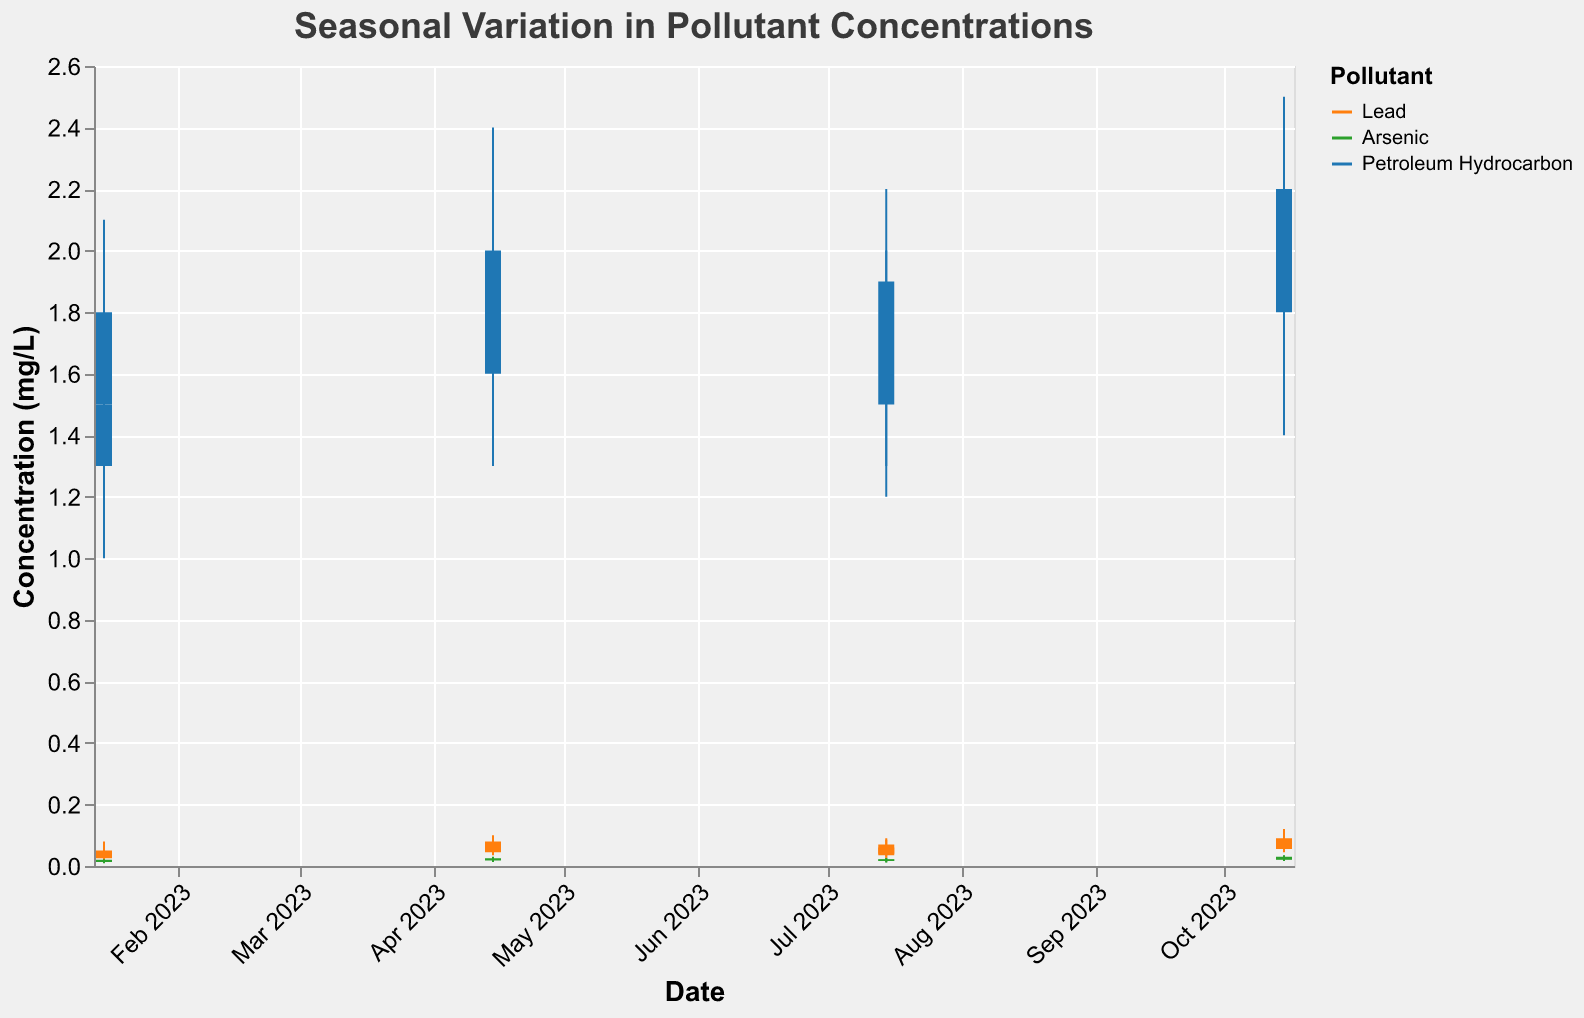What's the title of the figure? The title is displayed at the top of the figure.
Answer: Seasonal Variation in Pollutant Concentrations Which pollutant has the highest concentration in the River Thames in October 2023? Look for the highest "High Concentration (mg/L)" value in the River Thames column for October 2023. Petroleum Hydrocarbon has a high concentration of 2.5 mg/L.
Answer: Petroleum Hydrocarbon What is the average close concentration of Lead in River Thames across all seasons? Sum the close concentrations in River Thames for all seasons and divide by the number of seasons. (0.05 + 0.08 + 0.07 + 0.09) / 4 = 0.0725 mg/L.
Answer: 0.0725 mg/L Which location, River Thames or Colorado River, has higher average concentrations of Arsenic over the year? Calculate the average concentration of Arsenic for both locations by summing values and dividing by 4. River Thames: (0.020 + 0.025 + 0.022 + 0.030)/4 = 0.02425 mg/L, Colorado River: (0.018 + 0.023 + 0.021 + 0.027)/4 = 0.02225 mg/L.
Answer: River Thames During which season was the range of Lead concentration the highest in Colorado River? For each season in Colorado River, subtract "Low Concentration (mg/L)" from "High Concentration (mg/L)" for Lead to find the range: Jan (0.055), Apr (0.06), Jul (0.06), Oct (0.065). Highest range is in October.
Answer: Autumn (October) How does the concentration of Petroleum Hydrocarbon in Colorado River in July compare to River Thames in the same month? Compare the close concentrations: Colorado River (1.7 mg/L) vs. River Thames (1.9 mg/L).
Answer: Colorado River has lower concentration Which pollutant shows the least seasonal variation in the River Thames? Determine pollutant with smallest range between its lowest and highest concentrations across all seasons: Lead (0.10), Arsenic (0.025), Petroleum Hydrocarbon (1.3). Arsenic has the smallest range.
Answer: Arsenic Has the concentration of Lead continually increased in River Thames from January to October 2023? Check close concentrations of Lead in River Thames for each season in order: January (0.05), April (0.08), July (0.07), October (0.09). It does not continually increase.
Answer: No What is the difference in the close concentration of Petroleum Hydrocarbon between Colorado River and River Thames in January 2023? Subtract the close concentration values for Petroleum Hydrocarbon in January 2023: River Thames (1.8) - Colorado River (1.5).
Answer: 0.3 mg/L Which month exhibited the highest concentration of Arsenic in any location? Identify the highest "High Concentration (mg/L)" value for Arsenic: River Thames in October (0.035) vs. Colorado River in October (0.033). River Thames in October is highest.
Answer: October 